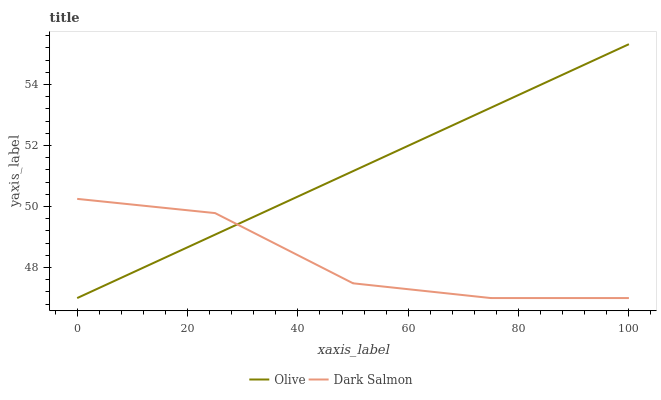Does Dark Salmon have the minimum area under the curve?
Answer yes or no. Yes. Does Olive have the maximum area under the curve?
Answer yes or no. Yes. Does Dark Salmon have the maximum area under the curve?
Answer yes or no. No. Is Olive the smoothest?
Answer yes or no. Yes. Is Dark Salmon the roughest?
Answer yes or no. Yes. Is Dark Salmon the smoothest?
Answer yes or no. No. Does Olive have the lowest value?
Answer yes or no. Yes. Does Olive have the highest value?
Answer yes or no. Yes. Does Dark Salmon have the highest value?
Answer yes or no. No. Does Olive intersect Dark Salmon?
Answer yes or no. Yes. Is Olive less than Dark Salmon?
Answer yes or no. No. Is Olive greater than Dark Salmon?
Answer yes or no. No. 